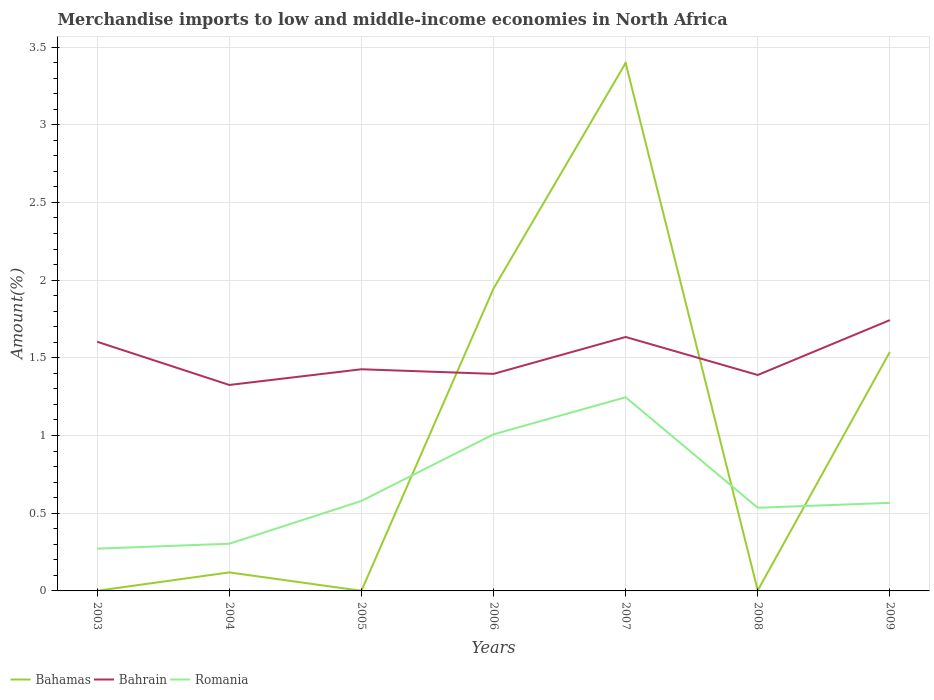Does the line corresponding to Bahrain intersect with the line corresponding to Romania?
Offer a very short reply. No. Across all years, what is the maximum percentage of amount earned from merchandise imports in Bahrain?
Provide a succinct answer. 1.33. What is the total percentage of amount earned from merchandise imports in Romania in the graph?
Your answer should be very brief. -0.26. What is the difference between the highest and the second highest percentage of amount earned from merchandise imports in Bahamas?
Keep it short and to the point. 3.4. What is the difference between the highest and the lowest percentage of amount earned from merchandise imports in Bahamas?
Ensure brevity in your answer.  3. Is the percentage of amount earned from merchandise imports in Bahamas strictly greater than the percentage of amount earned from merchandise imports in Bahrain over the years?
Your answer should be very brief. No. How many lines are there?
Offer a very short reply. 3. How many years are there in the graph?
Keep it short and to the point. 7. Are the values on the major ticks of Y-axis written in scientific E-notation?
Your response must be concise. No. Does the graph contain any zero values?
Your answer should be compact. No. Does the graph contain grids?
Give a very brief answer. Yes. How many legend labels are there?
Your answer should be compact. 3. How are the legend labels stacked?
Your response must be concise. Horizontal. What is the title of the graph?
Your answer should be very brief. Merchandise imports to low and middle-income economies in North Africa. Does "Heavily indebted poor countries" appear as one of the legend labels in the graph?
Give a very brief answer. No. What is the label or title of the Y-axis?
Provide a succinct answer. Amount(%). What is the Amount(%) of Bahamas in 2003?
Offer a terse response. 0. What is the Amount(%) in Bahrain in 2003?
Ensure brevity in your answer.  1.6. What is the Amount(%) of Romania in 2003?
Provide a succinct answer. 0.27. What is the Amount(%) of Bahamas in 2004?
Provide a short and direct response. 0.12. What is the Amount(%) in Bahrain in 2004?
Your response must be concise. 1.33. What is the Amount(%) of Romania in 2004?
Ensure brevity in your answer.  0.3. What is the Amount(%) in Bahamas in 2005?
Keep it short and to the point. 0. What is the Amount(%) in Bahrain in 2005?
Offer a terse response. 1.43. What is the Amount(%) in Romania in 2005?
Give a very brief answer. 0.58. What is the Amount(%) of Bahamas in 2006?
Offer a very short reply. 1.95. What is the Amount(%) of Bahrain in 2006?
Your response must be concise. 1.4. What is the Amount(%) of Romania in 2006?
Make the answer very short. 1.01. What is the Amount(%) in Bahamas in 2007?
Offer a very short reply. 3.4. What is the Amount(%) of Bahrain in 2007?
Offer a very short reply. 1.63. What is the Amount(%) of Romania in 2007?
Keep it short and to the point. 1.25. What is the Amount(%) of Bahamas in 2008?
Your answer should be compact. 0. What is the Amount(%) in Bahrain in 2008?
Keep it short and to the point. 1.39. What is the Amount(%) in Romania in 2008?
Make the answer very short. 0.54. What is the Amount(%) of Bahamas in 2009?
Ensure brevity in your answer.  1.54. What is the Amount(%) in Bahrain in 2009?
Offer a terse response. 1.74. What is the Amount(%) of Romania in 2009?
Offer a very short reply. 0.57. Across all years, what is the maximum Amount(%) of Bahamas?
Offer a terse response. 3.4. Across all years, what is the maximum Amount(%) in Bahrain?
Keep it short and to the point. 1.74. Across all years, what is the maximum Amount(%) of Romania?
Your answer should be compact. 1.25. Across all years, what is the minimum Amount(%) of Bahamas?
Ensure brevity in your answer.  0. Across all years, what is the minimum Amount(%) of Bahrain?
Your answer should be compact. 1.33. Across all years, what is the minimum Amount(%) in Romania?
Your response must be concise. 0.27. What is the total Amount(%) in Bahamas in the graph?
Offer a terse response. 7. What is the total Amount(%) in Bahrain in the graph?
Your response must be concise. 10.52. What is the total Amount(%) of Romania in the graph?
Your response must be concise. 4.51. What is the difference between the Amount(%) in Bahamas in 2003 and that in 2004?
Provide a short and direct response. -0.12. What is the difference between the Amount(%) in Bahrain in 2003 and that in 2004?
Offer a very short reply. 0.28. What is the difference between the Amount(%) in Romania in 2003 and that in 2004?
Your answer should be very brief. -0.03. What is the difference between the Amount(%) in Bahrain in 2003 and that in 2005?
Your response must be concise. 0.18. What is the difference between the Amount(%) of Romania in 2003 and that in 2005?
Keep it short and to the point. -0.31. What is the difference between the Amount(%) of Bahamas in 2003 and that in 2006?
Your response must be concise. -1.94. What is the difference between the Amount(%) of Bahrain in 2003 and that in 2006?
Give a very brief answer. 0.21. What is the difference between the Amount(%) in Romania in 2003 and that in 2006?
Provide a short and direct response. -0.74. What is the difference between the Amount(%) of Bahamas in 2003 and that in 2007?
Your answer should be very brief. -3.4. What is the difference between the Amount(%) of Bahrain in 2003 and that in 2007?
Provide a succinct answer. -0.03. What is the difference between the Amount(%) in Romania in 2003 and that in 2007?
Offer a very short reply. -0.97. What is the difference between the Amount(%) in Bahamas in 2003 and that in 2008?
Provide a succinct answer. -0. What is the difference between the Amount(%) of Bahrain in 2003 and that in 2008?
Keep it short and to the point. 0.21. What is the difference between the Amount(%) in Romania in 2003 and that in 2008?
Your answer should be compact. -0.26. What is the difference between the Amount(%) of Bahamas in 2003 and that in 2009?
Offer a very short reply. -1.54. What is the difference between the Amount(%) of Bahrain in 2003 and that in 2009?
Keep it short and to the point. -0.14. What is the difference between the Amount(%) of Romania in 2003 and that in 2009?
Your answer should be compact. -0.29. What is the difference between the Amount(%) in Bahamas in 2004 and that in 2005?
Offer a very short reply. 0.12. What is the difference between the Amount(%) of Bahrain in 2004 and that in 2005?
Keep it short and to the point. -0.1. What is the difference between the Amount(%) of Romania in 2004 and that in 2005?
Provide a short and direct response. -0.28. What is the difference between the Amount(%) of Bahamas in 2004 and that in 2006?
Keep it short and to the point. -1.83. What is the difference between the Amount(%) in Bahrain in 2004 and that in 2006?
Offer a terse response. -0.07. What is the difference between the Amount(%) in Romania in 2004 and that in 2006?
Provide a short and direct response. -0.7. What is the difference between the Amount(%) in Bahamas in 2004 and that in 2007?
Make the answer very short. -3.28. What is the difference between the Amount(%) in Bahrain in 2004 and that in 2007?
Make the answer very short. -0.31. What is the difference between the Amount(%) in Romania in 2004 and that in 2007?
Offer a terse response. -0.94. What is the difference between the Amount(%) in Bahamas in 2004 and that in 2008?
Offer a very short reply. 0.12. What is the difference between the Amount(%) of Bahrain in 2004 and that in 2008?
Provide a short and direct response. -0.06. What is the difference between the Amount(%) in Romania in 2004 and that in 2008?
Your answer should be very brief. -0.23. What is the difference between the Amount(%) of Bahamas in 2004 and that in 2009?
Offer a very short reply. -1.42. What is the difference between the Amount(%) in Bahrain in 2004 and that in 2009?
Give a very brief answer. -0.42. What is the difference between the Amount(%) of Romania in 2004 and that in 2009?
Make the answer very short. -0.26. What is the difference between the Amount(%) in Bahamas in 2005 and that in 2006?
Provide a succinct answer. -1.94. What is the difference between the Amount(%) of Bahrain in 2005 and that in 2006?
Offer a very short reply. 0.03. What is the difference between the Amount(%) of Romania in 2005 and that in 2006?
Your answer should be compact. -0.43. What is the difference between the Amount(%) of Bahamas in 2005 and that in 2007?
Ensure brevity in your answer.  -3.4. What is the difference between the Amount(%) in Bahrain in 2005 and that in 2007?
Your answer should be very brief. -0.21. What is the difference between the Amount(%) in Romania in 2005 and that in 2007?
Provide a succinct answer. -0.67. What is the difference between the Amount(%) in Bahamas in 2005 and that in 2008?
Offer a terse response. -0. What is the difference between the Amount(%) of Bahrain in 2005 and that in 2008?
Your response must be concise. 0.04. What is the difference between the Amount(%) in Romania in 2005 and that in 2008?
Provide a short and direct response. 0.04. What is the difference between the Amount(%) of Bahamas in 2005 and that in 2009?
Offer a very short reply. -1.54. What is the difference between the Amount(%) in Bahrain in 2005 and that in 2009?
Offer a terse response. -0.32. What is the difference between the Amount(%) of Romania in 2005 and that in 2009?
Your answer should be compact. 0.01. What is the difference between the Amount(%) of Bahamas in 2006 and that in 2007?
Ensure brevity in your answer.  -1.45. What is the difference between the Amount(%) of Bahrain in 2006 and that in 2007?
Make the answer very short. -0.24. What is the difference between the Amount(%) of Romania in 2006 and that in 2007?
Offer a terse response. -0.24. What is the difference between the Amount(%) in Bahamas in 2006 and that in 2008?
Keep it short and to the point. 1.94. What is the difference between the Amount(%) of Bahrain in 2006 and that in 2008?
Give a very brief answer. 0.01. What is the difference between the Amount(%) of Romania in 2006 and that in 2008?
Give a very brief answer. 0.47. What is the difference between the Amount(%) of Bahamas in 2006 and that in 2009?
Your answer should be compact. 0.41. What is the difference between the Amount(%) in Bahrain in 2006 and that in 2009?
Make the answer very short. -0.35. What is the difference between the Amount(%) of Romania in 2006 and that in 2009?
Provide a succinct answer. 0.44. What is the difference between the Amount(%) in Bahamas in 2007 and that in 2008?
Your answer should be compact. 3.39. What is the difference between the Amount(%) in Bahrain in 2007 and that in 2008?
Keep it short and to the point. 0.24. What is the difference between the Amount(%) of Romania in 2007 and that in 2008?
Your answer should be compact. 0.71. What is the difference between the Amount(%) in Bahamas in 2007 and that in 2009?
Make the answer very short. 1.86. What is the difference between the Amount(%) of Bahrain in 2007 and that in 2009?
Provide a succinct answer. -0.11. What is the difference between the Amount(%) of Romania in 2007 and that in 2009?
Your answer should be compact. 0.68. What is the difference between the Amount(%) of Bahamas in 2008 and that in 2009?
Your answer should be compact. -1.53. What is the difference between the Amount(%) in Bahrain in 2008 and that in 2009?
Your answer should be very brief. -0.35. What is the difference between the Amount(%) of Romania in 2008 and that in 2009?
Provide a succinct answer. -0.03. What is the difference between the Amount(%) in Bahamas in 2003 and the Amount(%) in Bahrain in 2004?
Provide a short and direct response. -1.32. What is the difference between the Amount(%) of Bahamas in 2003 and the Amount(%) of Romania in 2004?
Provide a short and direct response. -0.3. What is the difference between the Amount(%) in Bahrain in 2003 and the Amount(%) in Romania in 2004?
Ensure brevity in your answer.  1.3. What is the difference between the Amount(%) of Bahamas in 2003 and the Amount(%) of Bahrain in 2005?
Give a very brief answer. -1.43. What is the difference between the Amount(%) in Bahamas in 2003 and the Amount(%) in Romania in 2005?
Provide a succinct answer. -0.58. What is the difference between the Amount(%) of Bahrain in 2003 and the Amount(%) of Romania in 2005?
Your answer should be very brief. 1.02. What is the difference between the Amount(%) in Bahamas in 2003 and the Amount(%) in Bahrain in 2006?
Your answer should be very brief. -1.4. What is the difference between the Amount(%) of Bahamas in 2003 and the Amount(%) of Romania in 2006?
Your response must be concise. -1.01. What is the difference between the Amount(%) of Bahrain in 2003 and the Amount(%) of Romania in 2006?
Offer a very short reply. 0.6. What is the difference between the Amount(%) of Bahamas in 2003 and the Amount(%) of Bahrain in 2007?
Offer a very short reply. -1.63. What is the difference between the Amount(%) of Bahamas in 2003 and the Amount(%) of Romania in 2007?
Make the answer very short. -1.25. What is the difference between the Amount(%) of Bahrain in 2003 and the Amount(%) of Romania in 2007?
Provide a short and direct response. 0.36. What is the difference between the Amount(%) of Bahamas in 2003 and the Amount(%) of Bahrain in 2008?
Ensure brevity in your answer.  -1.39. What is the difference between the Amount(%) of Bahamas in 2003 and the Amount(%) of Romania in 2008?
Keep it short and to the point. -0.53. What is the difference between the Amount(%) in Bahrain in 2003 and the Amount(%) in Romania in 2008?
Provide a succinct answer. 1.07. What is the difference between the Amount(%) of Bahamas in 2003 and the Amount(%) of Bahrain in 2009?
Provide a succinct answer. -1.74. What is the difference between the Amount(%) in Bahamas in 2003 and the Amount(%) in Romania in 2009?
Ensure brevity in your answer.  -0.57. What is the difference between the Amount(%) of Bahrain in 2003 and the Amount(%) of Romania in 2009?
Give a very brief answer. 1.04. What is the difference between the Amount(%) of Bahamas in 2004 and the Amount(%) of Bahrain in 2005?
Your response must be concise. -1.31. What is the difference between the Amount(%) of Bahamas in 2004 and the Amount(%) of Romania in 2005?
Give a very brief answer. -0.46. What is the difference between the Amount(%) in Bahrain in 2004 and the Amount(%) in Romania in 2005?
Your response must be concise. 0.75. What is the difference between the Amount(%) in Bahamas in 2004 and the Amount(%) in Bahrain in 2006?
Keep it short and to the point. -1.28. What is the difference between the Amount(%) of Bahamas in 2004 and the Amount(%) of Romania in 2006?
Your response must be concise. -0.89. What is the difference between the Amount(%) of Bahrain in 2004 and the Amount(%) of Romania in 2006?
Keep it short and to the point. 0.32. What is the difference between the Amount(%) in Bahamas in 2004 and the Amount(%) in Bahrain in 2007?
Your response must be concise. -1.51. What is the difference between the Amount(%) of Bahamas in 2004 and the Amount(%) of Romania in 2007?
Your response must be concise. -1.13. What is the difference between the Amount(%) in Bahrain in 2004 and the Amount(%) in Romania in 2007?
Offer a very short reply. 0.08. What is the difference between the Amount(%) of Bahamas in 2004 and the Amount(%) of Bahrain in 2008?
Keep it short and to the point. -1.27. What is the difference between the Amount(%) in Bahamas in 2004 and the Amount(%) in Romania in 2008?
Give a very brief answer. -0.42. What is the difference between the Amount(%) of Bahrain in 2004 and the Amount(%) of Romania in 2008?
Provide a succinct answer. 0.79. What is the difference between the Amount(%) in Bahamas in 2004 and the Amount(%) in Bahrain in 2009?
Keep it short and to the point. -1.62. What is the difference between the Amount(%) of Bahamas in 2004 and the Amount(%) of Romania in 2009?
Provide a succinct answer. -0.45. What is the difference between the Amount(%) in Bahrain in 2004 and the Amount(%) in Romania in 2009?
Your answer should be very brief. 0.76. What is the difference between the Amount(%) in Bahamas in 2005 and the Amount(%) in Bahrain in 2006?
Offer a terse response. -1.4. What is the difference between the Amount(%) of Bahamas in 2005 and the Amount(%) of Romania in 2006?
Make the answer very short. -1.01. What is the difference between the Amount(%) of Bahrain in 2005 and the Amount(%) of Romania in 2006?
Your response must be concise. 0.42. What is the difference between the Amount(%) of Bahamas in 2005 and the Amount(%) of Bahrain in 2007?
Provide a short and direct response. -1.63. What is the difference between the Amount(%) of Bahamas in 2005 and the Amount(%) of Romania in 2007?
Your answer should be very brief. -1.25. What is the difference between the Amount(%) in Bahrain in 2005 and the Amount(%) in Romania in 2007?
Ensure brevity in your answer.  0.18. What is the difference between the Amount(%) of Bahamas in 2005 and the Amount(%) of Bahrain in 2008?
Your answer should be compact. -1.39. What is the difference between the Amount(%) of Bahamas in 2005 and the Amount(%) of Romania in 2008?
Your answer should be very brief. -0.53. What is the difference between the Amount(%) of Bahrain in 2005 and the Amount(%) of Romania in 2008?
Offer a very short reply. 0.89. What is the difference between the Amount(%) in Bahamas in 2005 and the Amount(%) in Bahrain in 2009?
Give a very brief answer. -1.74. What is the difference between the Amount(%) in Bahamas in 2005 and the Amount(%) in Romania in 2009?
Make the answer very short. -0.57. What is the difference between the Amount(%) of Bahrain in 2005 and the Amount(%) of Romania in 2009?
Ensure brevity in your answer.  0.86. What is the difference between the Amount(%) in Bahamas in 2006 and the Amount(%) in Bahrain in 2007?
Provide a succinct answer. 0.31. What is the difference between the Amount(%) in Bahamas in 2006 and the Amount(%) in Romania in 2007?
Offer a terse response. 0.7. What is the difference between the Amount(%) in Bahrain in 2006 and the Amount(%) in Romania in 2007?
Keep it short and to the point. 0.15. What is the difference between the Amount(%) in Bahamas in 2006 and the Amount(%) in Bahrain in 2008?
Your answer should be very brief. 0.56. What is the difference between the Amount(%) of Bahamas in 2006 and the Amount(%) of Romania in 2008?
Make the answer very short. 1.41. What is the difference between the Amount(%) of Bahrain in 2006 and the Amount(%) of Romania in 2008?
Offer a very short reply. 0.86. What is the difference between the Amount(%) in Bahamas in 2006 and the Amount(%) in Bahrain in 2009?
Provide a short and direct response. 0.2. What is the difference between the Amount(%) of Bahamas in 2006 and the Amount(%) of Romania in 2009?
Keep it short and to the point. 1.38. What is the difference between the Amount(%) of Bahrain in 2006 and the Amount(%) of Romania in 2009?
Offer a very short reply. 0.83. What is the difference between the Amount(%) in Bahamas in 2007 and the Amount(%) in Bahrain in 2008?
Give a very brief answer. 2.01. What is the difference between the Amount(%) of Bahamas in 2007 and the Amount(%) of Romania in 2008?
Make the answer very short. 2.86. What is the difference between the Amount(%) in Bahrain in 2007 and the Amount(%) in Romania in 2008?
Offer a terse response. 1.1. What is the difference between the Amount(%) in Bahamas in 2007 and the Amount(%) in Bahrain in 2009?
Keep it short and to the point. 1.65. What is the difference between the Amount(%) of Bahamas in 2007 and the Amount(%) of Romania in 2009?
Offer a terse response. 2.83. What is the difference between the Amount(%) of Bahrain in 2007 and the Amount(%) of Romania in 2009?
Offer a terse response. 1.07. What is the difference between the Amount(%) in Bahamas in 2008 and the Amount(%) in Bahrain in 2009?
Your response must be concise. -1.74. What is the difference between the Amount(%) in Bahamas in 2008 and the Amount(%) in Romania in 2009?
Your answer should be very brief. -0.56. What is the difference between the Amount(%) of Bahrain in 2008 and the Amount(%) of Romania in 2009?
Provide a succinct answer. 0.82. What is the average Amount(%) in Bahamas per year?
Your answer should be compact. 1. What is the average Amount(%) of Bahrain per year?
Your response must be concise. 1.5. What is the average Amount(%) in Romania per year?
Provide a short and direct response. 0.64. In the year 2003, what is the difference between the Amount(%) of Bahamas and Amount(%) of Bahrain?
Keep it short and to the point. -1.6. In the year 2003, what is the difference between the Amount(%) of Bahamas and Amount(%) of Romania?
Your answer should be compact. -0.27. In the year 2003, what is the difference between the Amount(%) in Bahrain and Amount(%) in Romania?
Provide a succinct answer. 1.33. In the year 2004, what is the difference between the Amount(%) of Bahamas and Amount(%) of Bahrain?
Ensure brevity in your answer.  -1.21. In the year 2004, what is the difference between the Amount(%) of Bahamas and Amount(%) of Romania?
Ensure brevity in your answer.  -0.18. In the year 2004, what is the difference between the Amount(%) of Bahrain and Amount(%) of Romania?
Offer a very short reply. 1.02. In the year 2005, what is the difference between the Amount(%) of Bahamas and Amount(%) of Bahrain?
Offer a very short reply. -1.43. In the year 2005, what is the difference between the Amount(%) of Bahamas and Amount(%) of Romania?
Offer a terse response. -0.58. In the year 2005, what is the difference between the Amount(%) in Bahrain and Amount(%) in Romania?
Ensure brevity in your answer.  0.85. In the year 2006, what is the difference between the Amount(%) of Bahamas and Amount(%) of Bahrain?
Your answer should be compact. 0.55. In the year 2006, what is the difference between the Amount(%) in Bahamas and Amount(%) in Romania?
Make the answer very short. 0.94. In the year 2006, what is the difference between the Amount(%) of Bahrain and Amount(%) of Romania?
Ensure brevity in your answer.  0.39. In the year 2007, what is the difference between the Amount(%) of Bahamas and Amount(%) of Bahrain?
Provide a short and direct response. 1.76. In the year 2007, what is the difference between the Amount(%) in Bahamas and Amount(%) in Romania?
Offer a terse response. 2.15. In the year 2007, what is the difference between the Amount(%) of Bahrain and Amount(%) of Romania?
Offer a very short reply. 0.39. In the year 2008, what is the difference between the Amount(%) of Bahamas and Amount(%) of Bahrain?
Offer a very short reply. -1.39. In the year 2008, what is the difference between the Amount(%) in Bahamas and Amount(%) in Romania?
Offer a terse response. -0.53. In the year 2008, what is the difference between the Amount(%) in Bahrain and Amount(%) in Romania?
Your answer should be compact. 0.85. In the year 2009, what is the difference between the Amount(%) of Bahamas and Amount(%) of Bahrain?
Your answer should be very brief. -0.2. In the year 2009, what is the difference between the Amount(%) in Bahamas and Amount(%) in Romania?
Provide a short and direct response. 0.97. In the year 2009, what is the difference between the Amount(%) of Bahrain and Amount(%) of Romania?
Provide a succinct answer. 1.18. What is the ratio of the Amount(%) in Bahamas in 2003 to that in 2004?
Make the answer very short. 0.01. What is the ratio of the Amount(%) in Bahrain in 2003 to that in 2004?
Ensure brevity in your answer.  1.21. What is the ratio of the Amount(%) in Romania in 2003 to that in 2004?
Provide a succinct answer. 0.9. What is the ratio of the Amount(%) of Bahamas in 2003 to that in 2005?
Your answer should be very brief. 1.27. What is the ratio of the Amount(%) in Bahrain in 2003 to that in 2005?
Your answer should be very brief. 1.12. What is the ratio of the Amount(%) in Romania in 2003 to that in 2005?
Provide a short and direct response. 0.47. What is the ratio of the Amount(%) in Bahrain in 2003 to that in 2006?
Provide a succinct answer. 1.15. What is the ratio of the Amount(%) in Romania in 2003 to that in 2006?
Offer a terse response. 0.27. What is the ratio of the Amount(%) in Bahamas in 2003 to that in 2007?
Make the answer very short. 0. What is the ratio of the Amount(%) of Bahrain in 2003 to that in 2007?
Provide a short and direct response. 0.98. What is the ratio of the Amount(%) in Romania in 2003 to that in 2007?
Give a very brief answer. 0.22. What is the ratio of the Amount(%) in Bahamas in 2003 to that in 2008?
Ensure brevity in your answer.  0.34. What is the ratio of the Amount(%) in Bahrain in 2003 to that in 2008?
Offer a very short reply. 1.15. What is the ratio of the Amount(%) of Romania in 2003 to that in 2008?
Give a very brief answer. 0.51. What is the ratio of the Amount(%) in Bahamas in 2003 to that in 2009?
Your answer should be compact. 0. What is the ratio of the Amount(%) of Bahrain in 2003 to that in 2009?
Give a very brief answer. 0.92. What is the ratio of the Amount(%) in Romania in 2003 to that in 2009?
Your answer should be very brief. 0.48. What is the ratio of the Amount(%) of Bahamas in 2004 to that in 2005?
Your answer should be compact. 148.63. What is the ratio of the Amount(%) in Bahrain in 2004 to that in 2005?
Keep it short and to the point. 0.93. What is the ratio of the Amount(%) in Romania in 2004 to that in 2005?
Give a very brief answer. 0.52. What is the ratio of the Amount(%) of Bahamas in 2004 to that in 2006?
Your answer should be very brief. 0.06. What is the ratio of the Amount(%) of Bahrain in 2004 to that in 2006?
Offer a terse response. 0.95. What is the ratio of the Amount(%) of Romania in 2004 to that in 2006?
Your answer should be very brief. 0.3. What is the ratio of the Amount(%) in Bahamas in 2004 to that in 2007?
Offer a very short reply. 0.04. What is the ratio of the Amount(%) in Bahrain in 2004 to that in 2007?
Your response must be concise. 0.81. What is the ratio of the Amount(%) in Romania in 2004 to that in 2007?
Offer a terse response. 0.24. What is the ratio of the Amount(%) of Bahamas in 2004 to that in 2008?
Offer a terse response. 39.93. What is the ratio of the Amount(%) of Bahrain in 2004 to that in 2008?
Offer a terse response. 0.95. What is the ratio of the Amount(%) in Romania in 2004 to that in 2008?
Provide a succinct answer. 0.57. What is the ratio of the Amount(%) of Bahamas in 2004 to that in 2009?
Keep it short and to the point. 0.08. What is the ratio of the Amount(%) in Bahrain in 2004 to that in 2009?
Offer a very short reply. 0.76. What is the ratio of the Amount(%) in Romania in 2004 to that in 2009?
Your answer should be compact. 0.54. What is the ratio of the Amount(%) of Bahamas in 2005 to that in 2006?
Offer a terse response. 0. What is the ratio of the Amount(%) of Bahrain in 2005 to that in 2006?
Keep it short and to the point. 1.02. What is the ratio of the Amount(%) in Romania in 2005 to that in 2006?
Provide a short and direct response. 0.57. What is the ratio of the Amount(%) of Bahamas in 2005 to that in 2007?
Make the answer very short. 0. What is the ratio of the Amount(%) in Bahrain in 2005 to that in 2007?
Provide a succinct answer. 0.87. What is the ratio of the Amount(%) of Romania in 2005 to that in 2007?
Make the answer very short. 0.46. What is the ratio of the Amount(%) in Bahamas in 2005 to that in 2008?
Provide a short and direct response. 0.27. What is the ratio of the Amount(%) in Bahrain in 2005 to that in 2008?
Keep it short and to the point. 1.03. What is the ratio of the Amount(%) of Romania in 2005 to that in 2008?
Offer a very short reply. 1.08. What is the ratio of the Amount(%) of Bahamas in 2005 to that in 2009?
Offer a terse response. 0. What is the ratio of the Amount(%) of Bahrain in 2005 to that in 2009?
Keep it short and to the point. 0.82. What is the ratio of the Amount(%) of Romania in 2005 to that in 2009?
Ensure brevity in your answer.  1.02. What is the ratio of the Amount(%) of Bahamas in 2006 to that in 2007?
Your answer should be very brief. 0.57. What is the ratio of the Amount(%) of Bahrain in 2006 to that in 2007?
Provide a succinct answer. 0.85. What is the ratio of the Amount(%) in Romania in 2006 to that in 2007?
Ensure brevity in your answer.  0.81. What is the ratio of the Amount(%) of Bahamas in 2006 to that in 2008?
Make the answer very short. 652.46. What is the ratio of the Amount(%) in Romania in 2006 to that in 2008?
Offer a terse response. 1.88. What is the ratio of the Amount(%) in Bahamas in 2006 to that in 2009?
Offer a very short reply. 1.26. What is the ratio of the Amount(%) in Bahrain in 2006 to that in 2009?
Offer a very short reply. 0.8. What is the ratio of the Amount(%) of Romania in 2006 to that in 2009?
Offer a terse response. 1.78. What is the ratio of the Amount(%) in Bahamas in 2007 to that in 2008?
Offer a very short reply. 1139.3. What is the ratio of the Amount(%) of Bahrain in 2007 to that in 2008?
Give a very brief answer. 1.18. What is the ratio of the Amount(%) of Romania in 2007 to that in 2008?
Ensure brevity in your answer.  2.33. What is the ratio of the Amount(%) of Bahamas in 2007 to that in 2009?
Your answer should be compact. 2.21. What is the ratio of the Amount(%) in Bahrain in 2007 to that in 2009?
Keep it short and to the point. 0.94. What is the ratio of the Amount(%) of Romania in 2007 to that in 2009?
Your answer should be very brief. 2.2. What is the ratio of the Amount(%) in Bahamas in 2008 to that in 2009?
Ensure brevity in your answer.  0. What is the ratio of the Amount(%) of Bahrain in 2008 to that in 2009?
Offer a terse response. 0.8. What is the ratio of the Amount(%) in Romania in 2008 to that in 2009?
Your response must be concise. 0.94. What is the difference between the highest and the second highest Amount(%) in Bahamas?
Provide a succinct answer. 1.45. What is the difference between the highest and the second highest Amount(%) in Bahrain?
Offer a terse response. 0.11. What is the difference between the highest and the second highest Amount(%) of Romania?
Provide a succinct answer. 0.24. What is the difference between the highest and the lowest Amount(%) of Bahamas?
Your response must be concise. 3.4. What is the difference between the highest and the lowest Amount(%) in Bahrain?
Make the answer very short. 0.42. What is the difference between the highest and the lowest Amount(%) in Romania?
Keep it short and to the point. 0.97. 